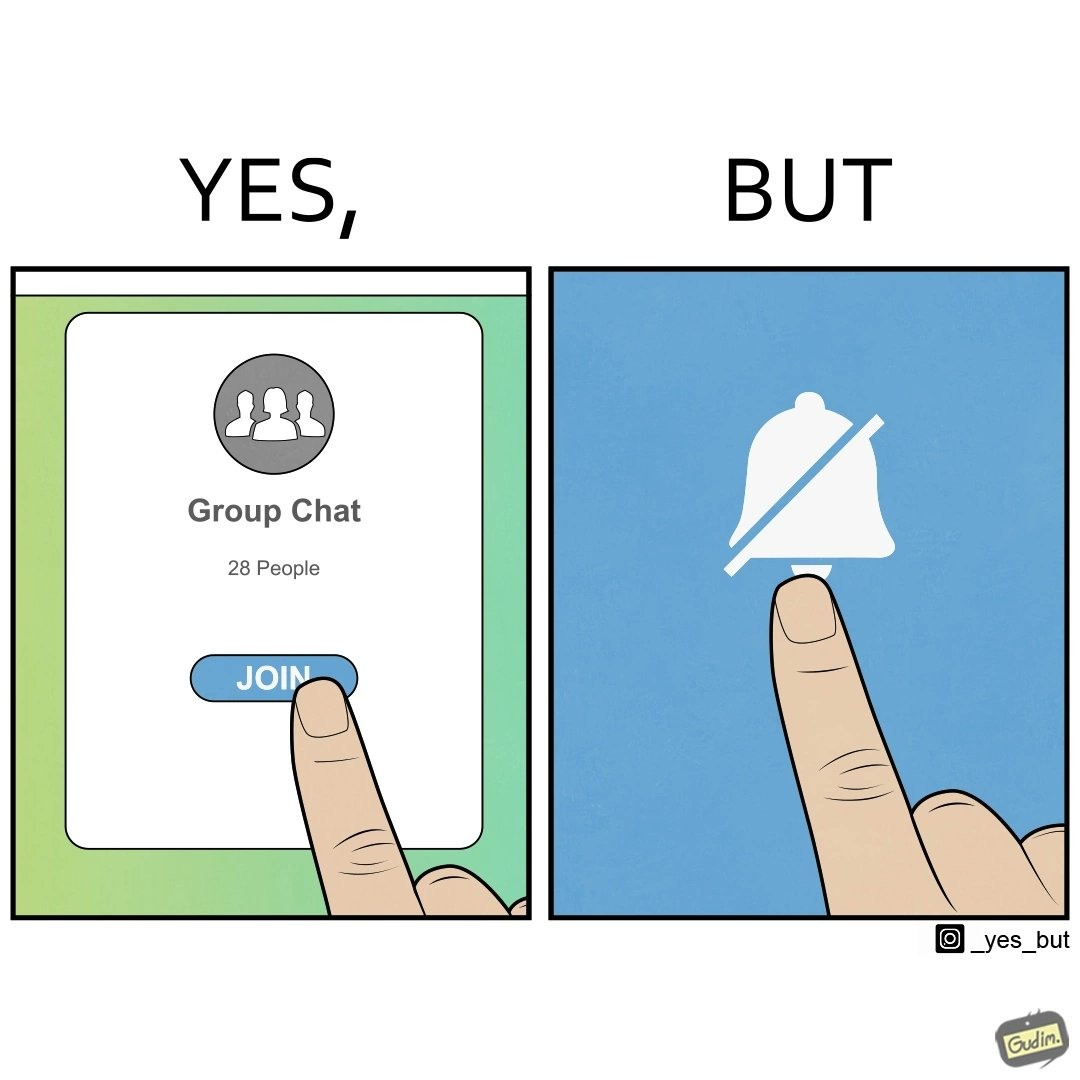Describe what you see in the left and right parts of this image. In the left part of the image: Close-up of phone screen, that has the phrase "Group Chat" on it, and the phrase "28 People" right below it. It  has button labeled "JOIN", and a person's finger is seen clicking the button. In the right part of the image: A touch screen with a "mute notifications" button symbol ( a bell icon that is struck through).  A person's finger is seen clicking the button. 